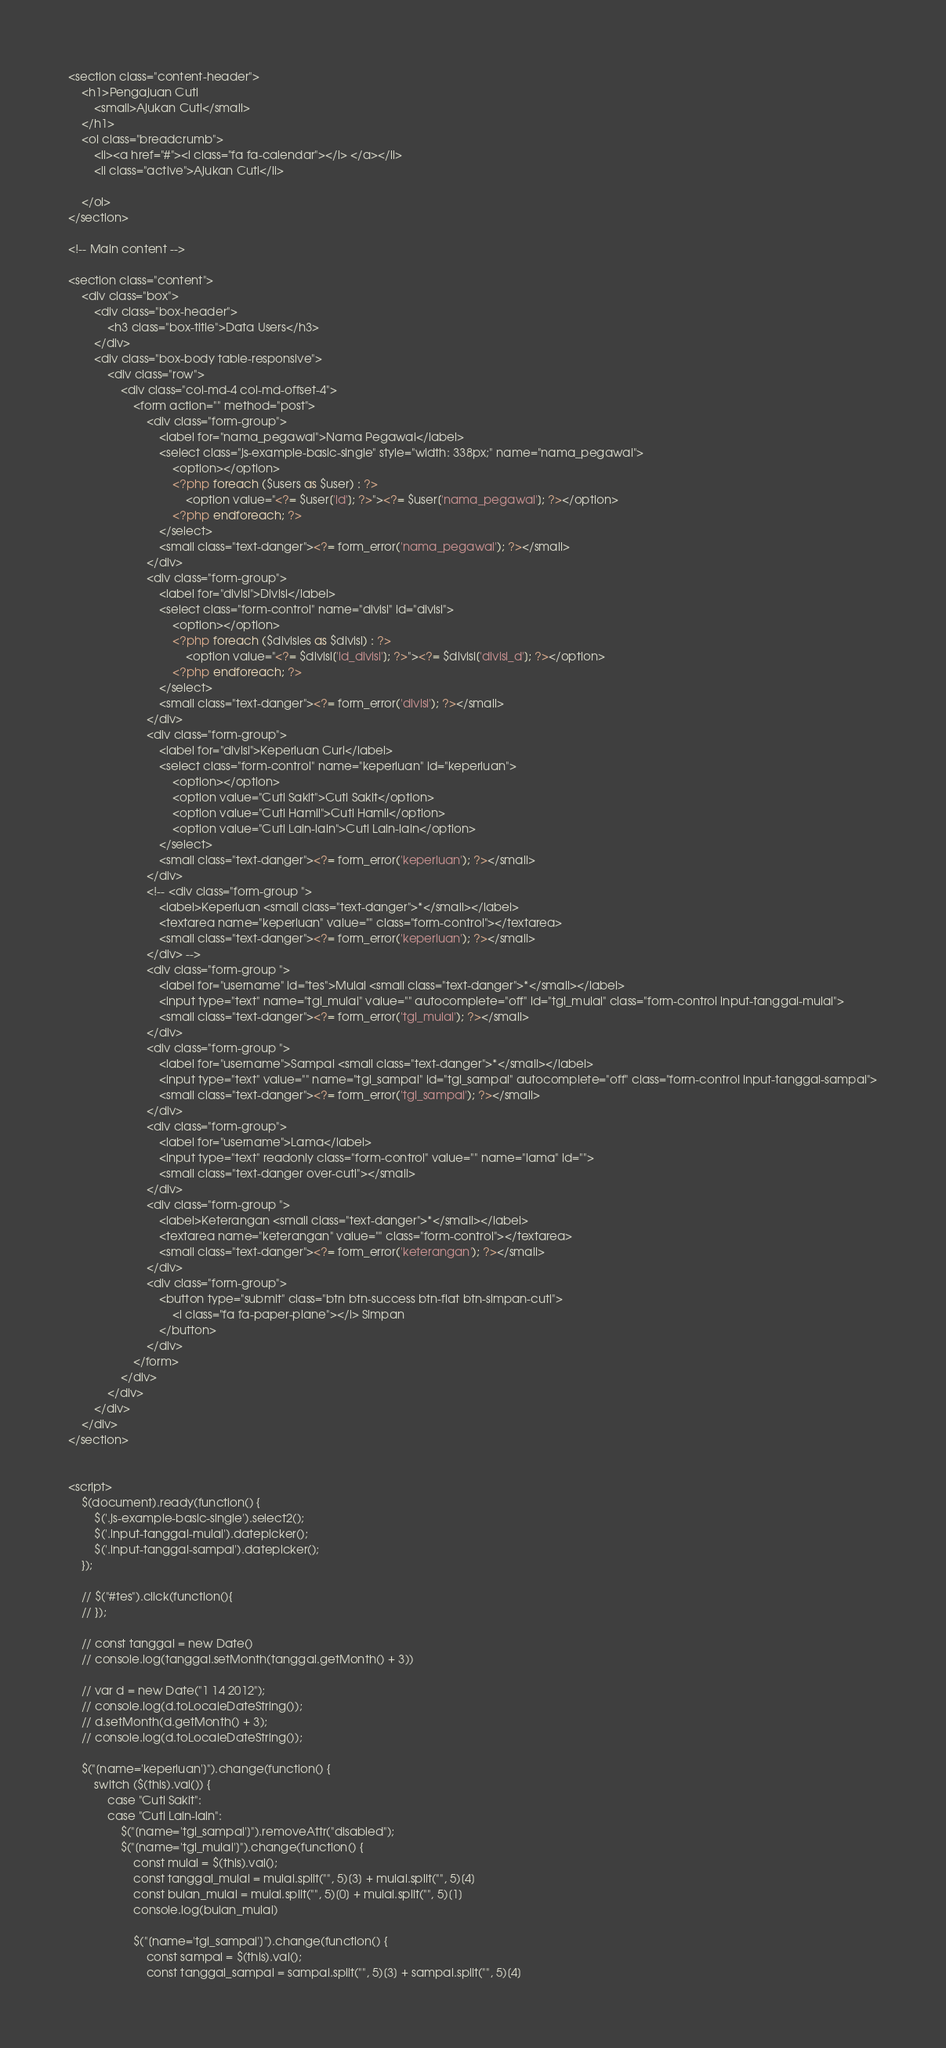Convert code to text. <code><loc_0><loc_0><loc_500><loc_500><_PHP_><section class="content-header">
    <h1>Pengajuan Cuti
        <small>Ajukan Cuti</small>
    </h1>
    <ol class="breadcrumb">
        <li><a href="#"><i class="fa fa-calendar"></i> </a></li>
        <li class="active">Ajukan Cuti</li>

    </ol>
</section>

<!-- Main content -->

<section class="content">
    <div class="box">
        <div class="box-header">
            <h3 class="box-title">Data Users</h3>
        </div>
        <div class="box-body table-responsive">
            <div class="row">
                <div class="col-md-4 col-md-offset-4">
                    <form action="" method="post">
                        <div class="form-group">
                            <label for="nama_pegawai">Nama Pegawai</label>
                            <select class="js-example-basic-single" style="width: 338px;" name="nama_pegawai">
                                <option></option>
                                <?php foreach ($users as $user) : ?>
                                    <option value="<?= $user['id']; ?>"><?= $user['nama_pegawai']; ?></option>
                                <?php endforeach; ?>
                            </select>
                            <small class="text-danger"><?= form_error('nama_pegawai'); ?></small>
                        </div>
                        <div class="form-group">
                            <label for="divisi">Divisi</label>
                            <select class="form-control" name="divisi" id="divisi">
                                <option></option>
                                <?php foreach ($divisies as $divisi) : ?>
                                    <option value="<?= $divisi['id_divisi']; ?>"><?= $divisi['divisi_d']; ?></option>
                                <?php endforeach; ?>
                            </select>
                            <small class="text-danger"><?= form_error('divisi'); ?></small>
                        </div>
                        <div class="form-group">
                            <label for="divisi">Keperluan Curi</label>
                            <select class="form-control" name="keperluan" id="keperluan">
                                <option></option>
                                <option value="Cuti Sakit">Cuti Sakit</option>
                                <option value="Cuti Hamil">Cuti Hamil</option>
                                <option value="Cuti Lain-lain">Cuti Lain-lain</option>
                            </select>
                            <small class="text-danger"><?= form_error('keperluan'); ?></small>
                        </div>
                        <!-- <div class="form-group ">
                            <label>Keperluan <small class="text-danger">*</small></label>
                            <textarea name="keperluan" value="" class="form-control"></textarea>
                            <small class="text-danger"><?= form_error('keperluan'); ?></small>
                        </div> -->
                        <div class="form-group ">
                            <label for="username" id="tes">Mulai <small class="text-danger">*</small></label>
                            <input type="text" name="tgl_mulai" value="" autocomplete="off" id="tgl_mulai" class="form-control input-tanggal-mulai">
                            <small class="text-danger"><?= form_error('tgl_mulai'); ?></small>
                        </div>
                        <div class="form-group ">
                            <label for="username">Sampai <small class="text-danger">*</small></label>
                            <input type="text" value="" name="tgl_sampai" id="tgl_sampai" autocomplete="off" class="form-control input-tanggal-sampai">
                            <small class="text-danger"><?= form_error('tgl_sampai'); ?></small>
                        </div>
                        <div class="form-group">
                            <label for="username">Lama</label>
                            <input type="text" readonly class="form-control" value="" name="lama" id="">
                            <small class="text-danger over-cuti"></small>
                        </div>
                        <div class="form-group ">
                            <label>Keterangan <small class="text-danger">*</small></label>
                            <textarea name="keterangan" value="" class="form-control"></textarea>
                            <small class="text-danger"><?= form_error('keterangan'); ?></small>
                        </div>
                        <div class="form-group">
                            <button type="submit" class="btn btn-success btn-flat btn-simpan-cuti">
                                <i class="fa fa-paper-plane"></i> Simpan
                            </button>
                        </div>
                    </form>
                </div>
            </div>
        </div>
    </div>
</section>


<script>
    $(document).ready(function() {
        $('.js-example-basic-single').select2();
        $('.input-tanggal-mulai').datepicker();
        $('.input-tanggal-sampai').datepicker();
    });

    // $("#tes").click(function(){
    // });

    // const tanggal = new Date()
    // console.log(tanggal.setMonth(tanggal.getMonth() + 3))

    // var d = new Date("1 14 2012");
    // console.log(d.toLocaleDateString());
    // d.setMonth(d.getMonth() + 3);
    // console.log(d.toLocaleDateString());

    $("[name='keperluan']").change(function() {
        switch ($(this).val()) {
            case "Cuti Sakit":
            case "Cuti Lain-lain":
                $("[name='tgl_sampai']").removeAttr("disabled");
                $("[name='tgl_mulai']").change(function() {
                    const mulai = $(this).val();
                    const tanggal_mulai = mulai.split("", 5)[3] + mulai.split("", 5)[4]
                    const bulan_mulai = mulai.split("", 5)[0] + mulai.split("", 5)[1]
                    console.log(bulan_mulai)

                    $("[name='tgl_sampai']").change(function() {
                        const sampai = $(this).val();
                        const tanggal_sampai = sampai.split("", 5)[3] + sampai.split("", 5)[4]</code> 